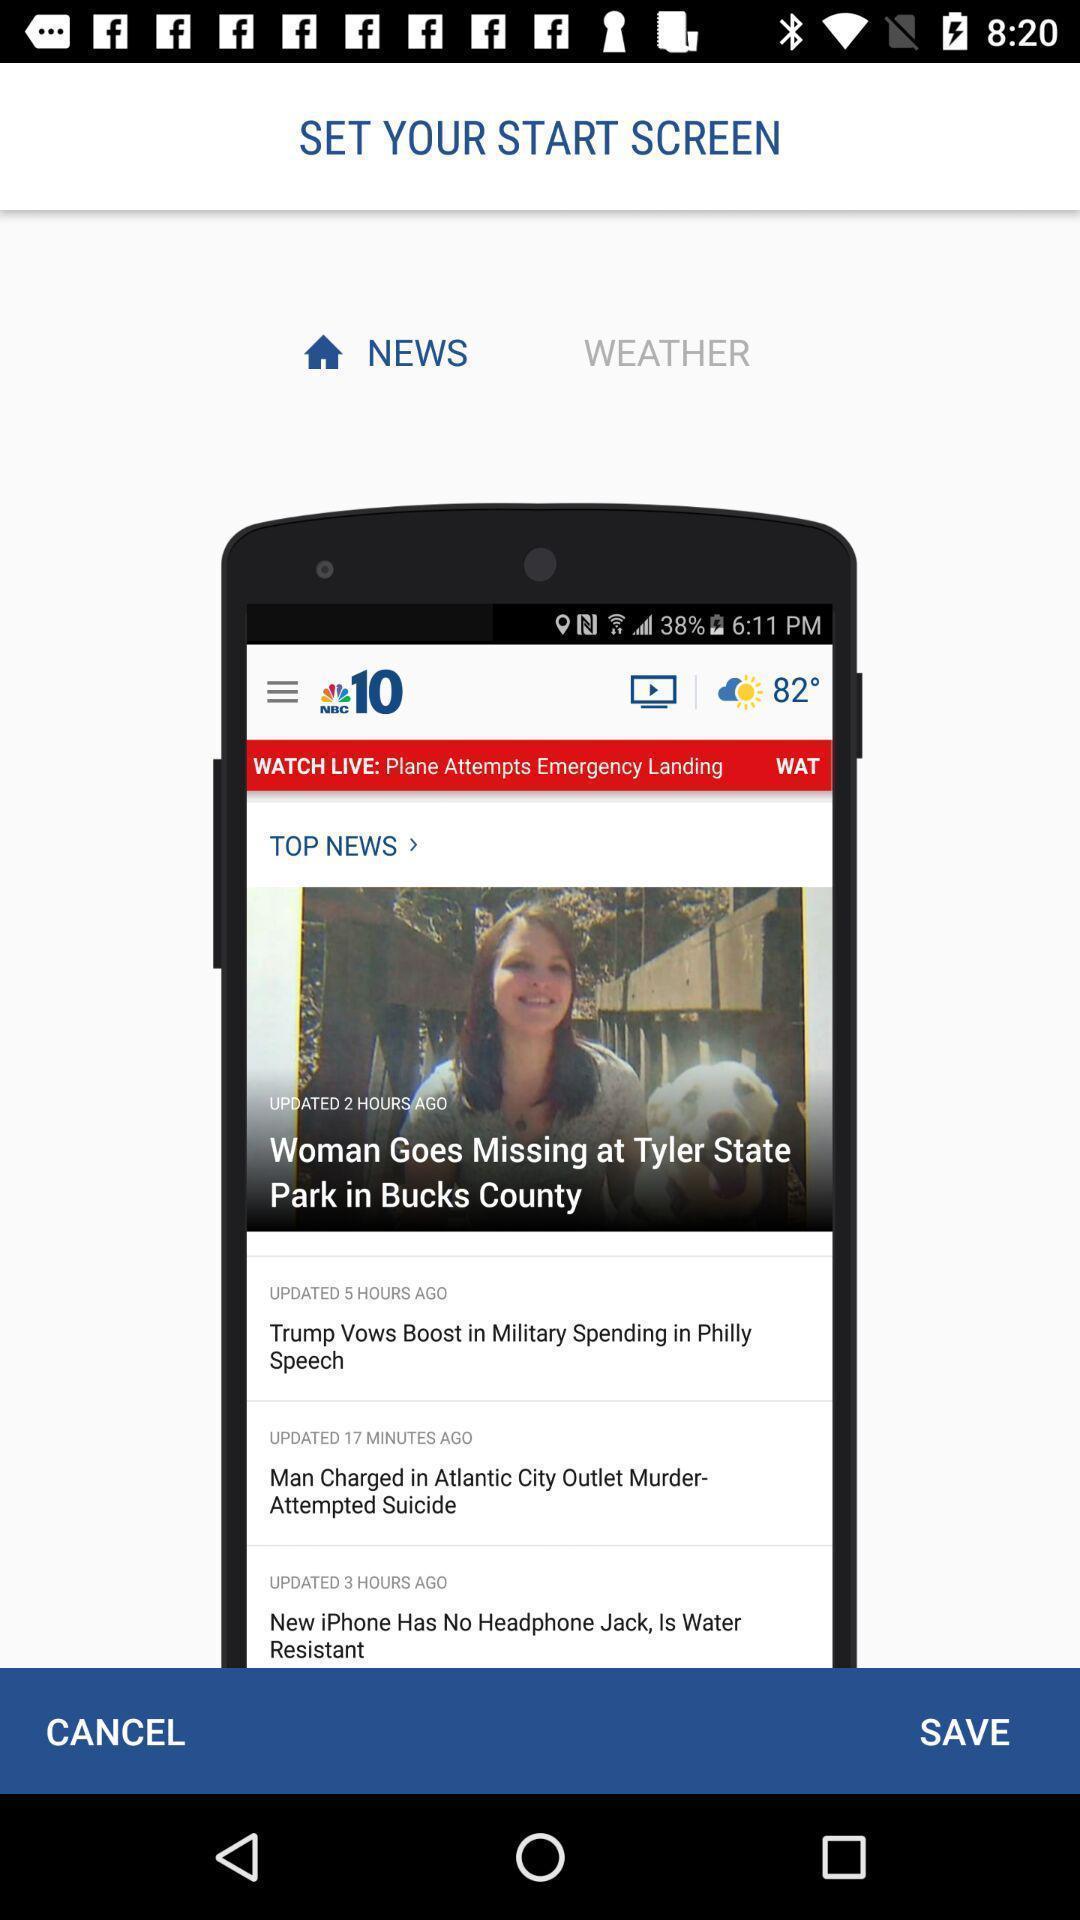Describe the content in this image. Welcome page. 